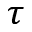<formula> <loc_0><loc_0><loc_500><loc_500>\tau</formula> 